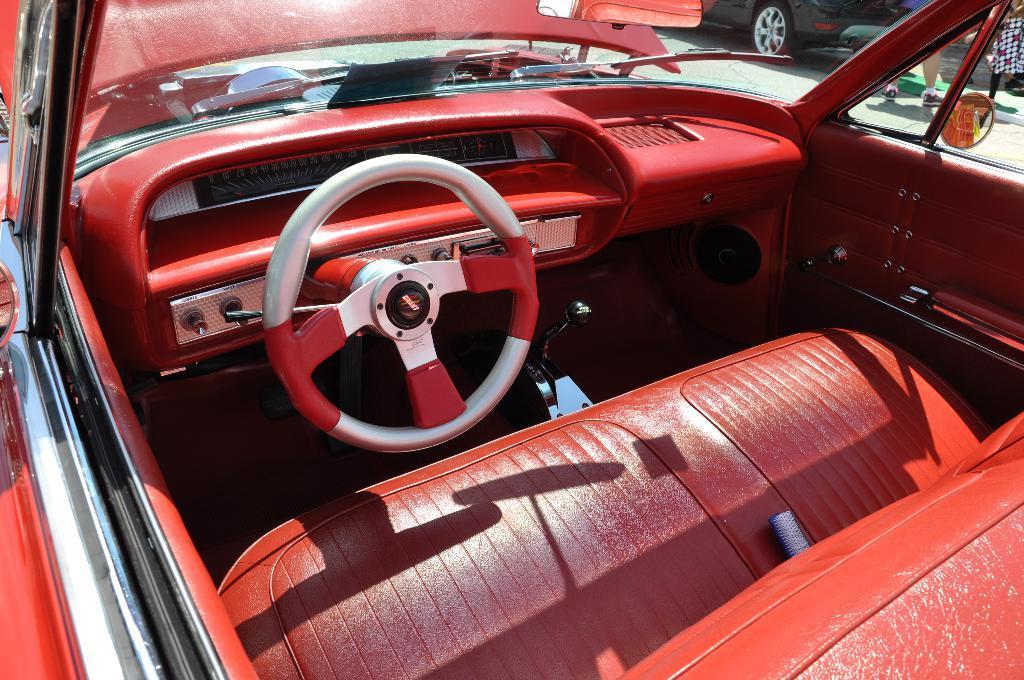In one or two sentences, can you explain what this image depicts? In this picture there is a car in the center of the image, which is red in color and there is another car and people at the top side of the image. 